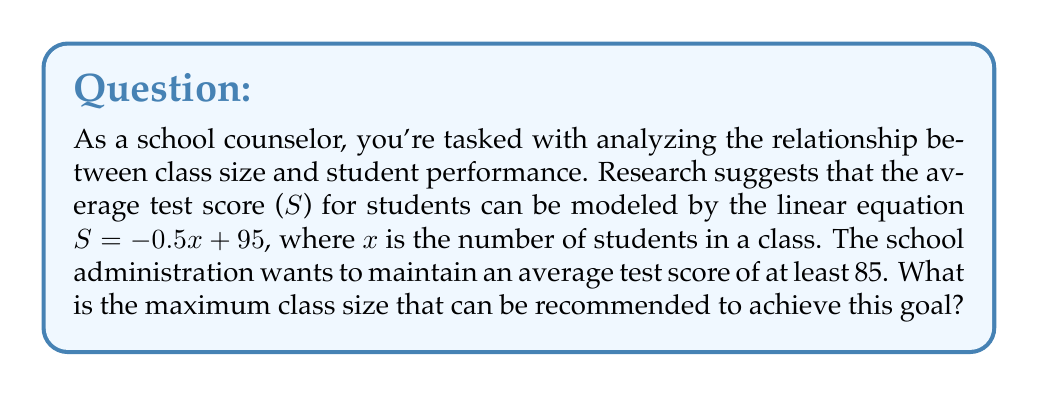Help me with this question. Let's approach this step-by-step:

1) We're given the linear equation: $S = -0.5x + 95$
   Where S is the average test score and x is the number of students in a class.

2) We want to find the maximum class size where the average score is at least 85.
   This means we need to solve the inequality:
   $$S \geq 85$$

3) Substituting our equation:
   $$-0.5x + 95 \geq 85$$

4) Subtract 95 from both sides:
   $$-0.5x \geq -10$$

5) Multiply both sides by -2 (remember to flip the inequality sign when multiplying by a negative):
   $$x \leq 20$$

6) Therefore, to maintain an average score of at least 85, the class size should not exceed 20 students.

7) Since we're asked for the maximum class size, and x represents the number of students (which must be a whole number), our answer is 20.

This analysis allows for an individualized learning plan by ensuring classes are small enough to maintain high performance while maximizing resources.
Answer: The maximum recommended class size is 20 students. 